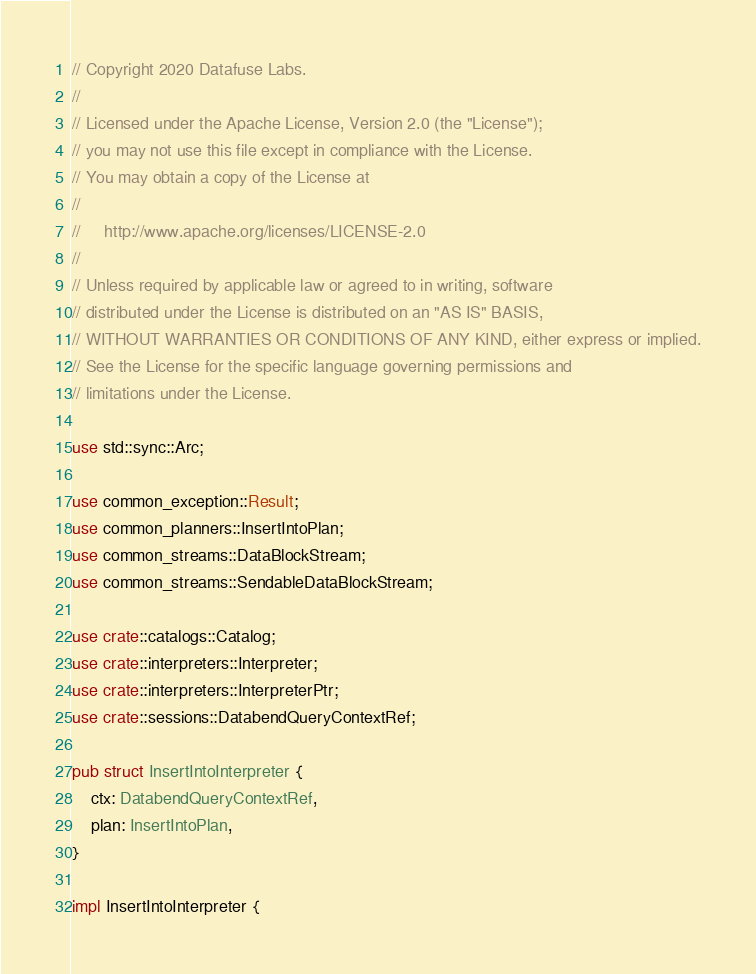<code> <loc_0><loc_0><loc_500><loc_500><_Rust_>// Copyright 2020 Datafuse Labs.
//
// Licensed under the Apache License, Version 2.0 (the "License");
// you may not use this file except in compliance with the License.
// You may obtain a copy of the License at
//
//     http://www.apache.org/licenses/LICENSE-2.0
//
// Unless required by applicable law or agreed to in writing, software
// distributed under the License is distributed on an "AS IS" BASIS,
// WITHOUT WARRANTIES OR CONDITIONS OF ANY KIND, either express or implied.
// See the License for the specific language governing permissions and
// limitations under the License.

use std::sync::Arc;

use common_exception::Result;
use common_planners::InsertIntoPlan;
use common_streams::DataBlockStream;
use common_streams::SendableDataBlockStream;

use crate::catalogs::Catalog;
use crate::interpreters::Interpreter;
use crate::interpreters::InterpreterPtr;
use crate::sessions::DatabendQueryContextRef;

pub struct InsertIntoInterpreter {
    ctx: DatabendQueryContextRef,
    plan: InsertIntoPlan,
}

impl InsertIntoInterpreter {</code> 